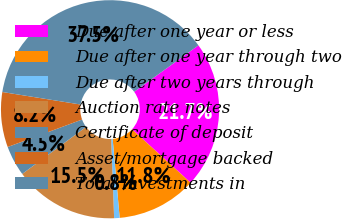<chart> <loc_0><loc_0><loc_500><loc_500><pie_chart><fcel>Due after one year or less<fcel>Due after one year through two<fcel>Due after two years through<fcel>Auction rate notes<fcel>Certificate of deposit<fcel>Asset/mortgage backed<fcel>Total investments in<nl><fcel>21.73%<fcel>11.82%<fcel>0.81%<fcel>15.49%<fcel>4.48%<fcel>8.15%<fcel>37.51%<nl></chart> 